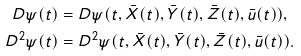<formula> <loc_0><loc_0><loc_500><loc_500>D \psi ( t ) & = D \psi ( t , \bar { X } ( t ) , \bar { Y } ( t ) , \bar { Z } ( t ) , \bar { u } ( t ) ) , \\ D ^ { 2 } \psi ( t ) & = D ^ { 2 } \psi ( t , \bar { X } ( t ) , \bar { Y } ( t ) , \bar { Z } ( t ) , \bar { u } ( t ) ) .</formula> 